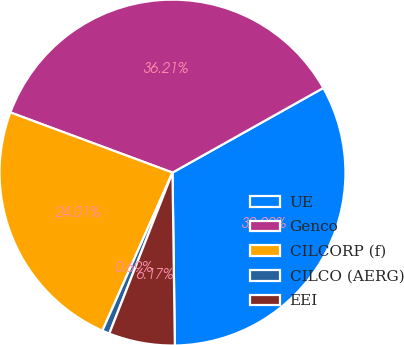<chart> <loc_0><loc_0><loc_500><loc_500><pie_chart><fcel>UE<fcel>Genco<fcel>CILCORP (f)<fcel>CILCO (AERG)<fcel>EEI<nl><fcel>32.92%<fcel>36.21%<fcel>24.01%<fcel>0.69%<fcel>6.17%<nl></chart> 